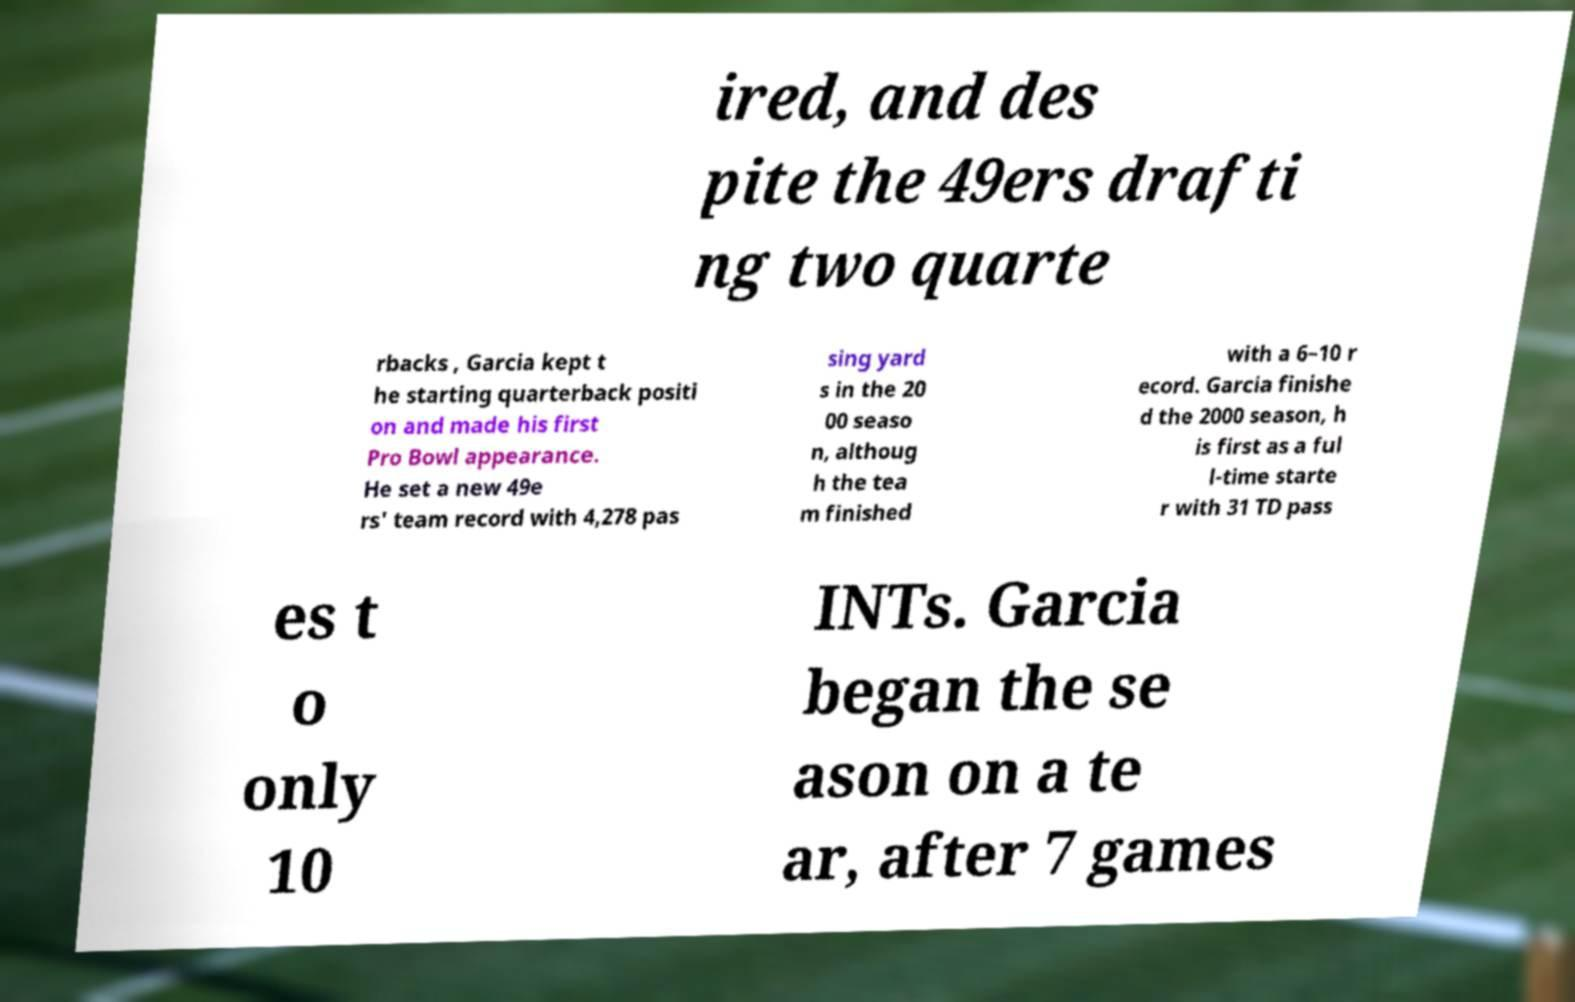What messages or text are displayed in this image? I need them in a readable, typed format. ired, and des pite the 49ers drafti ng two quarte rbacks , Garcia kept t he starting quarterback positi on and made his first Pro Bowl appearance. He set a new 49e rs' team record with 4,278 pas sing yard s in the 20 00 seaso n, althoug h the tea m finished with a 6–10 r ecord. Garcia finishe d the 2000 season, h is first as a ful l-time starte r with 31 TD pass es t o only 10 INTs. Garcia began the se ason on a te ar, after 7 games 